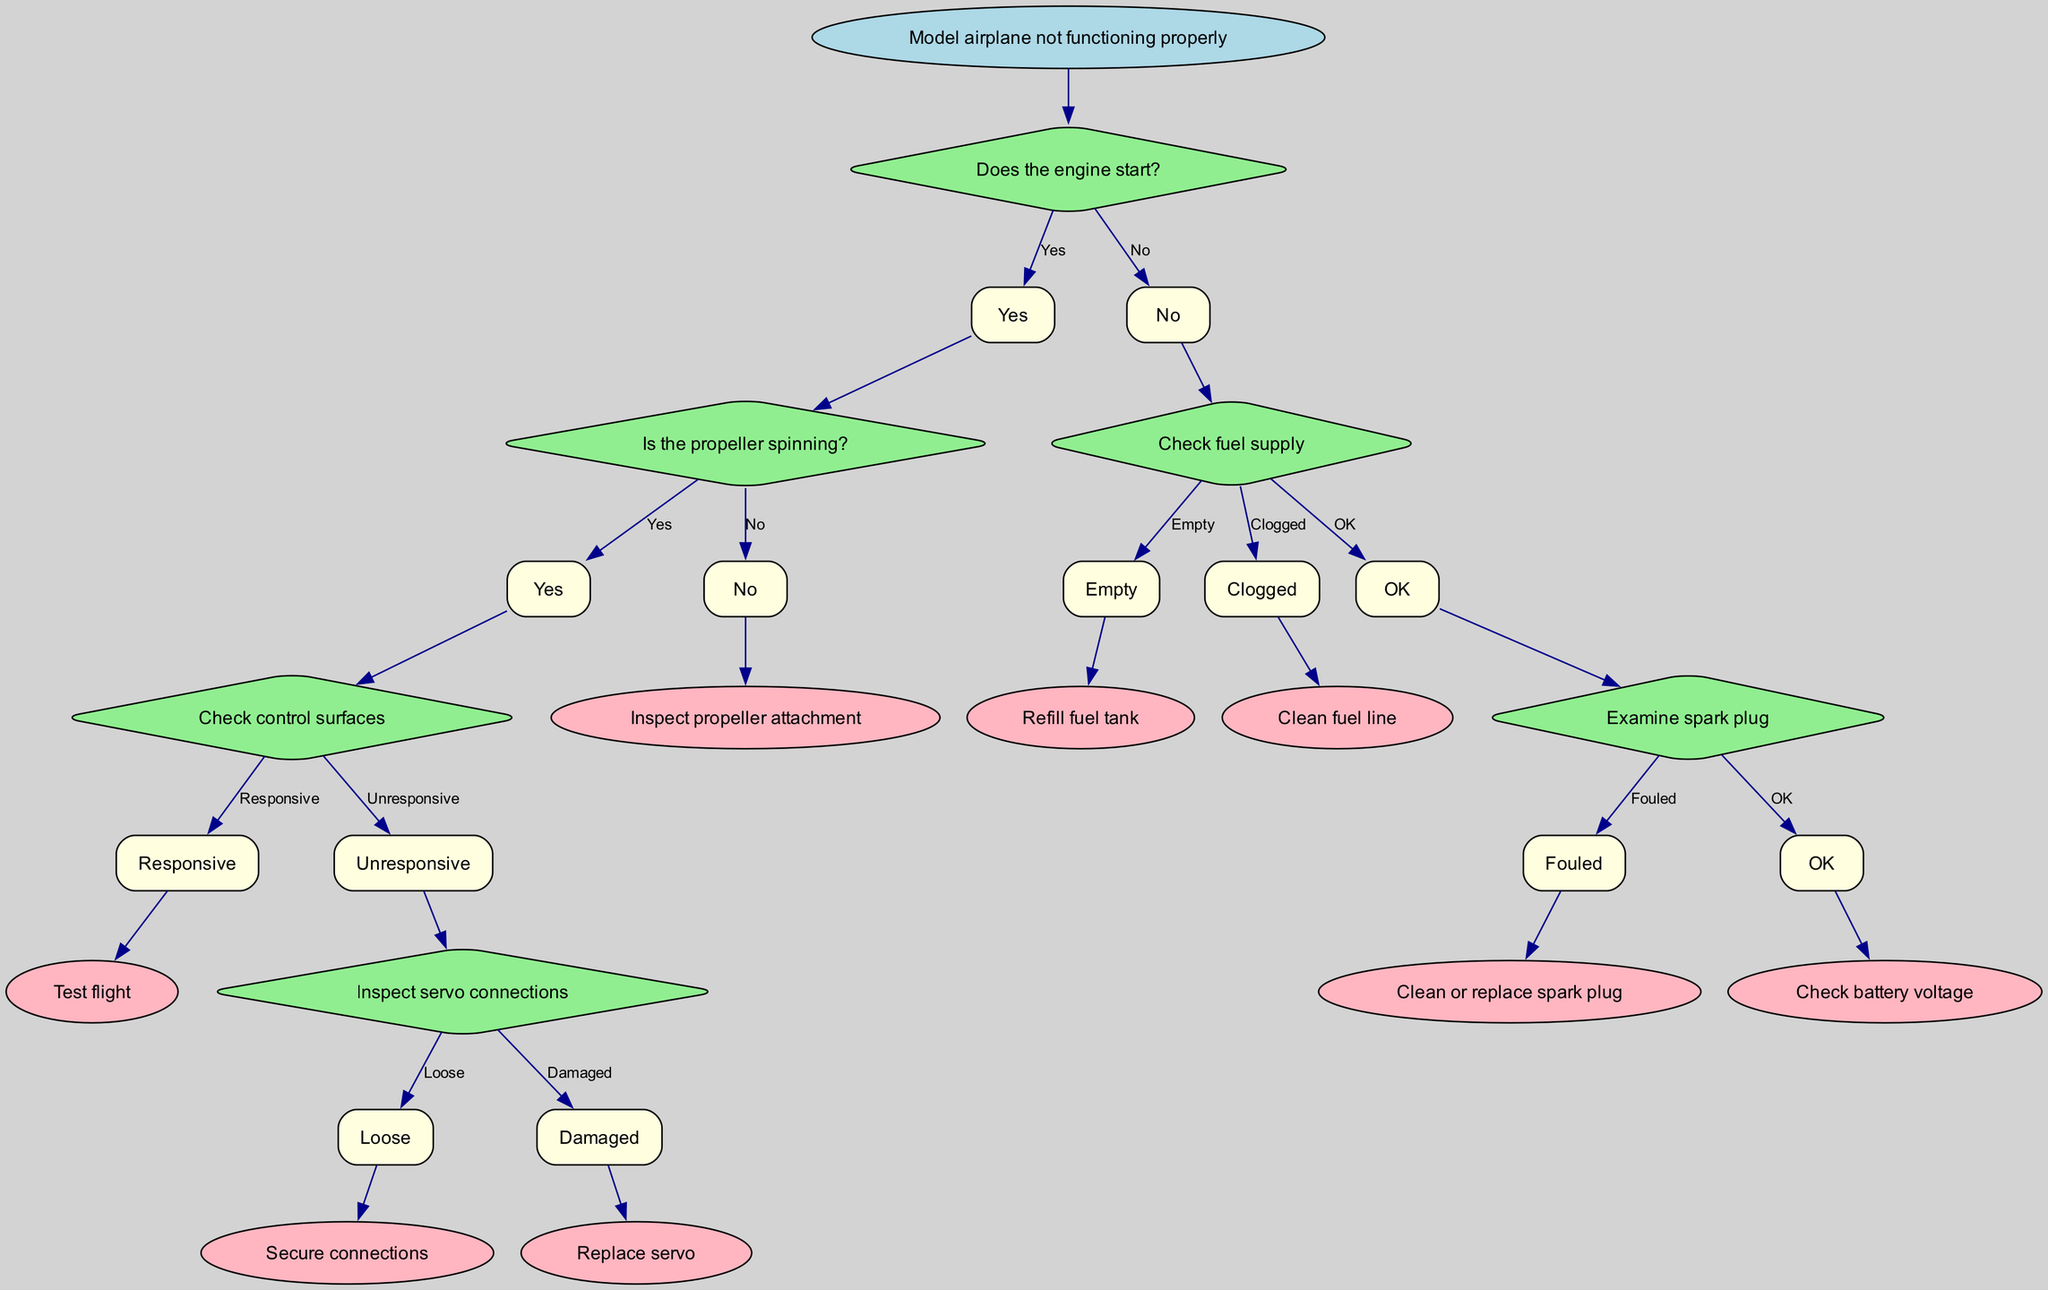What is the root node of the diagram? The root node of the diagram specifies the main issue being addressed, which is where the troubleshooting process begins. According to the data provided, it is "Model airplane not functioning properly."
Answer: Model airplane not functioning properly How many total nodes are present in the decision tree? To determine the total number of nodes, we count both the questions (diamond shapes) and outcomes (rectangles and the oval root). In this case, there are 7 nodes in total: 1 root node, 5 decision nodes, and 1 final result node.
Answer: 7 What happens if the engine starts but the propeller does not spin? According to the flow of the diagram, if the engine starts but the propeller does not spin, the next step is to "Inspect propeller attachment." This indicates a focus on the mechanism that connects the propeller to the engine.
Answer: Inspect propeller attachment What should be checked when the fuel supply indicates it's clogged? When the diagnosis reveals a clogged fuel supply, the next step to resolve the issue is "Clean fuel line." This step specifically addresses the blockage in the fuel pathway that could prevent proper engine operation.
Answer: Clean fuel line If the spark plug is found to be fouled, what action is recommended? The next action, when the spark plug is identified as fouled, is to "Clean or replace spark plug." This step aims to ensure a proper ignition process, which is critical for engine performance.
Answer: Clean or replace spark plug Which option is available if the control surfaces are responsive? When the control surfaces are confirmed to be responsive, the next step in the troubleshooting process is to conduct a "Test flight." This indicates readiness to confirm if the airplane operates correctly in actual flight conditions.
Answer: Test flight What does a diagnosis of "Damaged" indicate when inspecting servo connections? If servo connections are diagnosed as "Damaged," the necessary course of action is to "Replace servo." This decision reflects the need to ensure that control inputs can be effectively transmitted to the control surfaces for proper flight.
Answer: Replace servo What is the next step after confirming that the battery voltage is okay? If the battery voltage is confirmed to be okay, the process ends as there are no additional steps indicated in the decision tree beyond that point. It suggests readiness for flight as no further actions are necessary.
Answer: None (process ends) 